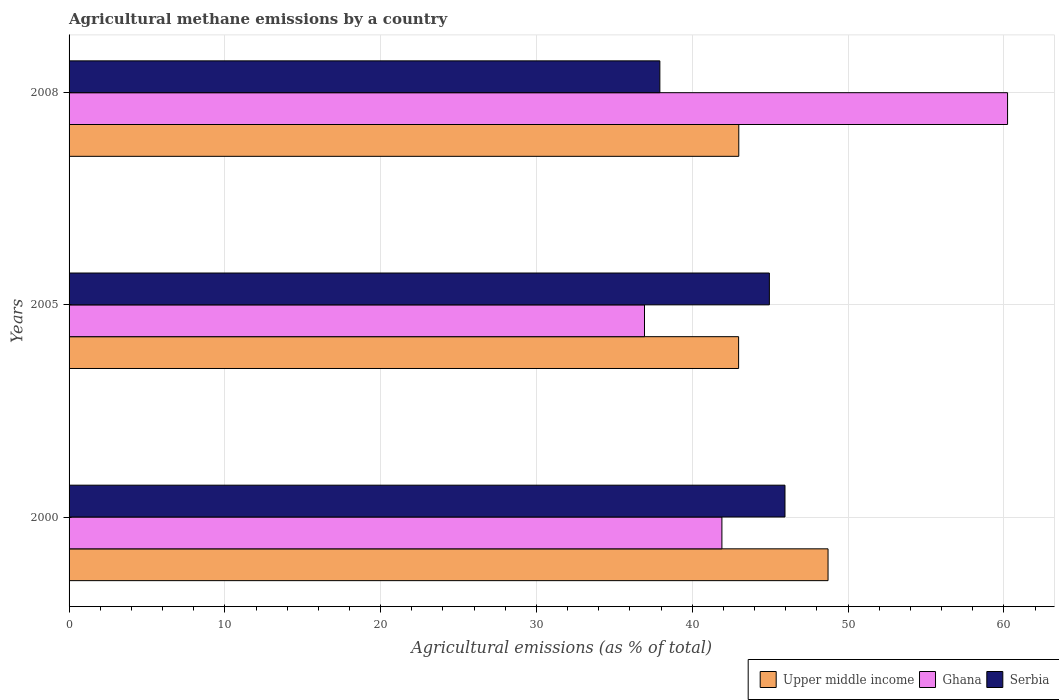How many different coloured bars are there?
Offer a terse response. 3. How many groups of bars are there?
Provide a short and direct response. 3. How many bars are there on the 2nd tick from the top?
Make the answer very short. 3. How many bars are there on the 3rd tick from the bottom?
Ensure brevity in your answer.  3. What is the label of the 3rd group of bars from the top?
Your answer should be compact. 2000. In how many cases, is the number of bars for a given year not equal to the number of legend labels?
Your answer should be compact. 0. What is the amount of agricultural methane emitted in Upper middle income in 2000?
Ensure brevity in your answer.  48.72. Across all years, what is the maximum amount of agricultural methane emitted in Serbia?
Your answer should be compact. 45.95. Across all years, what is the minimum amount of agricultural methane emitted in Upper middle income?
Keep it short and to the point. 42.98. In which year was the amount of agricultural methane emitted in Ghana maximum?
Make the answer very short. 2008. What is the total amount of agricultural methane emitted in Ghana in the graph?
Offer a terse response. 139.08. What is the difference between the amount of agricultural methane emitted in Upper middle income in 2000 and that in 2008?
Make the answer very short. 5.73. What is the difference between the amount of agricultural methane emitted in Serbia in 2005 and the amount of agricultural methane emitted in Upper middle income in 2008?
Your answer should be very brief. 1.96. What is the average amount of agricultural methane emitted in Serbia per year?
Your answer should be compact. 42.94. In the year 2000, what is the difference between the amount of agricultural methane emitted in Ghana and amount of agricultural methane emitted in Serbia?
Your answer should be compact. -4.05. In how many years, is the amount of agricultural methane emitted in Ghana greater than 36 %?
Your answer should be compact. 3. What is the ratio of the amount of agricultural methane emitted in Serbia in 2000 to that in 2008?
Offer a terse response. 1.21. Is the difference between the amount of agricultural methane emitted in Ghana in 2005 and 2008 greater than the difference between the amount of agricultural methane emitted in Serbia in 2005 and 2008?
Ensure brevity in your answer.  No. What is the difference between the highest and the second highest amount of agricultural methane emitted in Upper middle income?
Your answer should be very brief. 5.73. What is the difference between the highest and the lowest amount of agricultural methane emitted in Serbia?
Give a very brief answer. 8.03. What does the 3rd bar from the top in 2005 represents?
Offer a terse response. Upper middle income. Is it the case that in every year, the sum of the amount of agricultural methane emitted in Serbia and amount of agricultural methane emitted in Upper middle income is greater than the amount of agricultural methane emitted in Ghana?
Your answer should be compact. Yes. Are all the bars in the graph horizontal?
Your answer should be very brief. Yes. How many years are there in the graph?
Your answer should be very brief. 3. What is the difference between two consecutive major ticks on the X-axis?
Offer a terse response. 10. Does the graph contain any zero values?
Give a very brief answer. No. Does the graph contain grids?
Offer a very short reply. Yes. How many legend labels are there?
Your response must be concise. 3. What is the title of the graph?
Your answer should be very brief. Agricultural methane emissions by a country. Does "Panama" appear as one of the legend labels in the graph?
Give a very brief answer. No. What is the label or title of the X-axis?
Give a very brief answer. Agricultural emissions (as % of total). What is the label or title of the Y-axis?
Give a very brief answer. Years. What is the Agricultural emissions (as % of total) in Upper middle income in 2000?
Keep it short and to the point. 48.72. What is the Agricultural emissions (as % of total) of Ghana in 2000?
Provide a short and direct response. 41.9. What is the Agricultural emissions (as % of total) in Serbia in 2000?
Offer a terse response. 45.95. What is the Agricultural emissions (as % of total) of Upper middle income in 2005?
Provide a short and direct response. 42.98. What is the Agricultural emissions (as % of total) of Ghana in 2005?
Provide a succinct answer. 36.94. What is the Agricultural emissions (as % of total) of Serbia in 2005?
Give a very brief answer. 44.95. What is the Agricultural emissions (as % of total) in Upper middle income in 2008?
Offer a terse response. 42.99. What is the Agricultural emissions (as % of total) of Ghana in 2008?
Offer a very short reply. 60.24. What is the Agricultural emissions (as % of total) of Serbia in 2008?
Offer a very short reply. 37.92. Across all years, what is the maximum Agricultural emissions (as % of total) of Upper middle income?
Give a very brief answer. 48.72. Across all years, what is the maximum Agricultural emissions (as % of total) of Ghana?
Offer a very short reply. 60.24. Across all years, what is the maximum Agricultural emissions (as % of total) in Serbia?
Offer a terse response. 45.95. Across all years, what is the minimum Agricultural emissions (as % of total) in Upper middle income?
Keep it short and to the point. 42.98. Across all years, what is the minimum Agricultural emissions (as % of total) of Ghana?
Make the answer very short. 36.94. Across all years, what is the minimum Agricultural emissions (as % of total) of Serbia?
Give a very brief answer. 37.92. What is the total Agricultural emissions (as % of total) of Upper middle income in the graph?
Give a very brief answer. 134.68. What is the total Agricultural emissions (as % of total) of Ghana in the graph?
Offer a terse response. 139.08. What is the total Agricultural emissions (as % of total) in Serbia in the graph?
Offer a very short reply. 128.82. What is the difference between the Agricultural emissions (as % of total) in Upper middle income in 2000 and that in 2005?
Your response must be concise. 5.74. What is the difference between the Agricultural emissions (as % of total) of Ghana in 2000 and that in 2005?
Provide a short and direct response. 4.97. What is the difference between the Agricultural emissions (as % of total) of Upper middle income in 2000 and that in 2008?
Make the answer very short. 5.73. What is the difference between the Agricultural emissions (as % of total) of Ghana in 2000 and that in 2008?
Ensure brevity in your answer.  -18.34. What is the difference between the Agricultural emissions (as % of total) in Serbia in 2000 and that in 2008?
Keep it short and to the point. 8.03. What is the difference between the Agricultural emissions (as % of total) of Upper middle income in 2005 and that in 2008?
Ensure brevity in your answer.  -0.01. What is the difference between the Agricultural emissions (as % of total) in Ghana in 2005 and that in 2008?
Offer a terse response. -23.3. What is the difference between the Agricultural emissions (as % of total) of Serbia in 2005 and that in 2008?
Make the answer very short. 7.03. What is the difference between the Agricultural emissions (as % of total) of Upper middle income in 2000 and the Agricultural emissions (as % of total) of Ghana in 2005?
Offer a very short reply. 11.78. What is the difference between the Agricultural emissions (as % of total) in Upper middle income in 2000 and the Agricultural emissions (as % of total) in Serbia in 2005?
Provide a succinct answer. 3.77. What is the difference between the Agricultural emissions (as % of total) in Ghana in 2000 and the Agricultural emissions (as % of total) in Serbia in 2005?
Offer a terse response. -3.05. What is the difference between the Agricultural emissions (as % of total) in Upper middle income in 2000 and the Agricultural emissions (as % of total) in Ghana in 2008?
Offer a very short reply. -11.52. What is the difference between the Agricultural emissions (as % of total) of Upper middle income in 2000 and the Agricultural emissions (as % of total) of Serbia in 2008?
Your answer should be compact. 10.8. What is the difference between the Agricultural emissions (as % of total) of Ghana in 2000 and the Agricultural emissions (as % of total) of Serbia in 2008?
Provide a succinct answer. 3.98. What is the difference between the Agricultural emissions (as % of total) in Upper middle income in 2005 and the Agricultural emissions (as % of total) in Ghana in 2008?
Make the answer very short. -17.26. What is the difference between the Agricultural emissions (as % of total) in Upper middle income in 2005 and the Agricultural emissions (as % of total) in Serbia in 2008?
Make the answer very short. 5.05. What is the difference between the Agricultural emissions (as % of total) of Ghana in 2005 and the Agricultural emissions (as % of total) of Serbia in 2008?
Make the answer very short. -0.99. What is the average Agricultural emissions (as % of total) of Upper middle income per year?
Give a very brief answer. 44.89. What is the average Agricultural emissions (as % of total) of Ghana per year?
Make the answer very short. 46.36. What is the average Agricultural emissions (as % of total) in Serbia per year?
Ensure brevity in your answer.  42.94. In the year 2000, what is the difference between the Agricultural emissions (as % of total) of Upper middle income and Agricultural emissions (as % of total) of Ghana?
Ensure brevity in your answer.  6.81. In the year 2000, what is the difference between the Agricultural emissions (as % of total) in Upper middle income and Agricultural emissions (as % of total) in Serbia?
Your response must be concise. 2.76. In the year 2000, what is the difference between the Agricultural emissions (as % of total) of Ghana and Agricultural emissions (as % of total) of Serbia?
Ensure brevity in your answer.  -4.05. In the year 2005, what is the difference between the Agricultural emissions (as % of total) of Upper middle income and Agricultural emissions (as % of total) of Ghana?
Ensure brevity in your answer.  6.04. In the year 2005, what is the difference between the Agricultural emissions (as % of total) of Upper middle income and Agricultural emissions (as % of total) of Serbia?
Offer a terse response. -1.97. In the year 2005, what is the difference between the Agricultural emissions (as % of total) of Ghana and Agricultural emissions (as % of total) of Serbia?
Keep it short and to the point. -8.02. In the year 2008, what is the difference between the Agricultural emissions (as % of total) of Upper middle income and Agricultural emissions (as % of total) of Ghana?
Your answer should be compact. -17.25. In the year 2008, what is the difference between the Agricultural emissions (as % of total) of Upper middle income and Agricultural emissions (as % of total) of Serbia?
Provide a succinct answer. 5.07. In the year 2008, what is the difference between the Agricultural emissions (as % of total) in Ghana and Agricultural emissions (as % of total) in Serbia?
Your answer should be compact. 22.32. What is the ratio of the Agricultural emissions (as % of total) of Upper middle income in 2000 to that in 2005?
Your answer should be very brief. 1.13. What is the ratio of the Agricultural emissions (as % of total) of Ghana in 2000 to that in 2005?
Provide a succinct answer. 1.13. What is the ratio of the Agricultural emissions (as % of total) of Serbia in 2000 to that in 2005?
Keep it short and to the point. 1.02. What is the ratio of the Agricultural emissions (as % of total) of Upper middle income in 2000 to that in 2008?
Your response must be concise. 1.13. What is the ratio of the Agricultural emissions (as % of total) of Ghana in 2000 to that in 2008?
Your answer should be compact. 0.7. What is the ratio of the Agricultural emissions (as % of total) of Serbia in 2000 to that in 2008?
Make the answer very short. 1.21. What is the ratio of the Agricultural emissions (as % of total) of Ghana in 2005 to that in 2008?
Provide a short and direct response. 0.61. What is the ratio of the Agricultural emissions (as % of total) in Serbia in 2005 to that in 2008?
Your answer should be very brief. 1.19. What is the difference between the highest and the second highest Agricultural emissions (as % of total) of Upper middle income?
Your answer should be compact. 5.73. What is the difference between the highest and the second highest Agricultural emissions (as % of total) in Ghana?
Offer a terse response. 18.34. What is the difference between the highest and the second highest Agricultural emissions (as % of total) in Serbia?
Give a very brief answer. 1. What is the difference between the highest and the lowest Agricultural emissions (as % of total) of Upper middle income?
Provide a succinct answer. 5.74. What is the difference between the highest and the lowest Agricultural emissions (as % of total) of Ghana?
Offer a terse response. 23.3. What is the difference between the highest and the lowest Agricultural emissions (as % of total) of Serbia?
Ensure brevity in your answer.  8.03. 